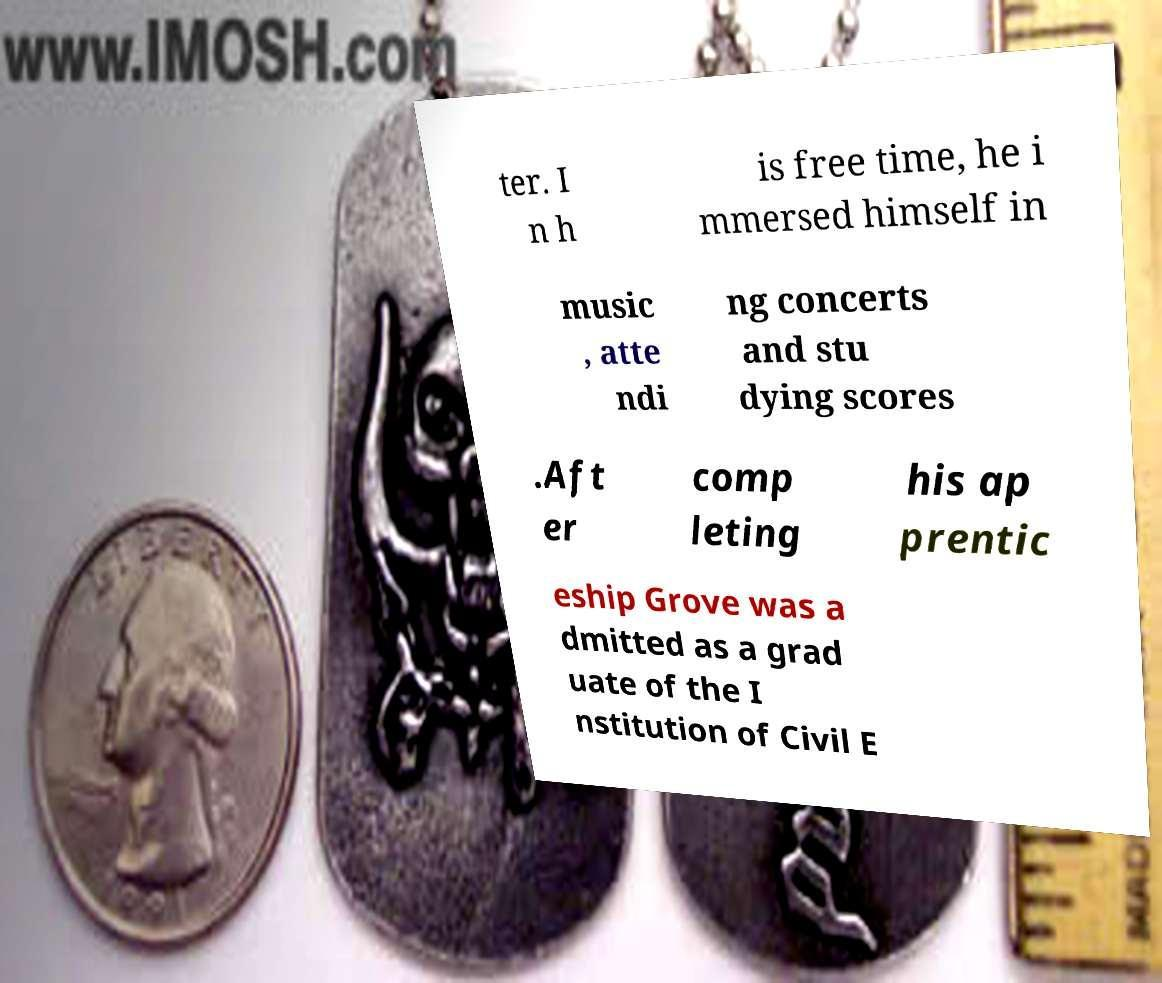Can you read and provide the text displayed in the image?This photo seems to have some interesting text. Can you extract and type it out for me? ter. I n h is free time, he i mmersed himself in music , atte ndi ng concerts and stu dying scores .Aft er comp leting his ap prentic eship Grove was a dmitted as a grad uate of the I nstitution of Civil E 